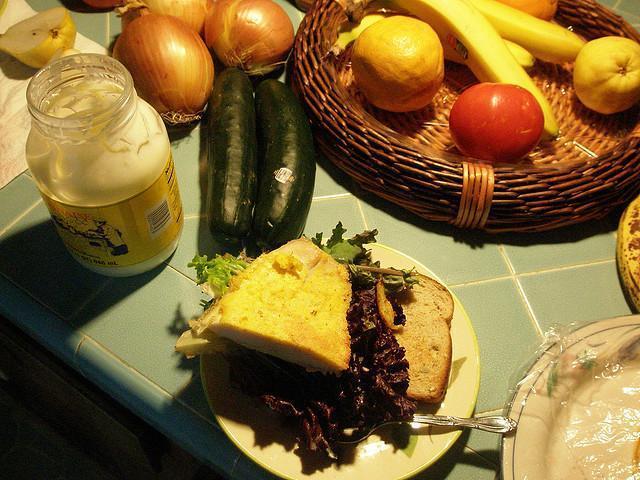How many different kinds of yellow fruit are in the bowl?
Give a very brief answer. 2. How many bananas can you see?
Give a very brief answer. 1. How many bottles are there?
Give a very brief answer. 1. How many apples are there?
Give a very brief answer. 2. How many oranges can you see?
Give a very brief answer. 2. 